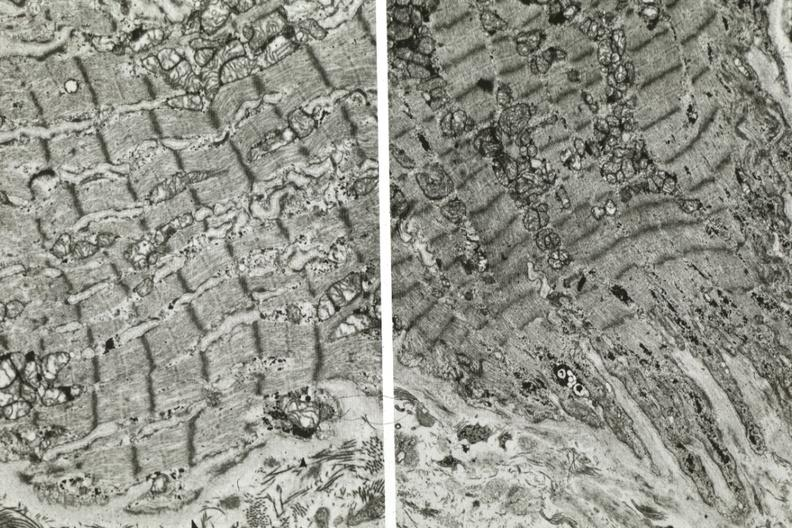s granulomata slide present?
Answer the question using a single word or phrase. No 